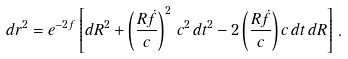<formula> <loc_0><loc_0><loc_500><loc_500>d r ^ { 2 } = e ^ { - 2 f } \left [ d R ^ { 2 } + \left ( \frac { R \dot { f } } { c } \right ) ^ { 2 } \, c ^ { 2 } \, d t ^ { 2 } - 2 \left ( \frac { R \dot { f } } { c } \right ) c \, d t \, d R \right ] \, .</formula> 